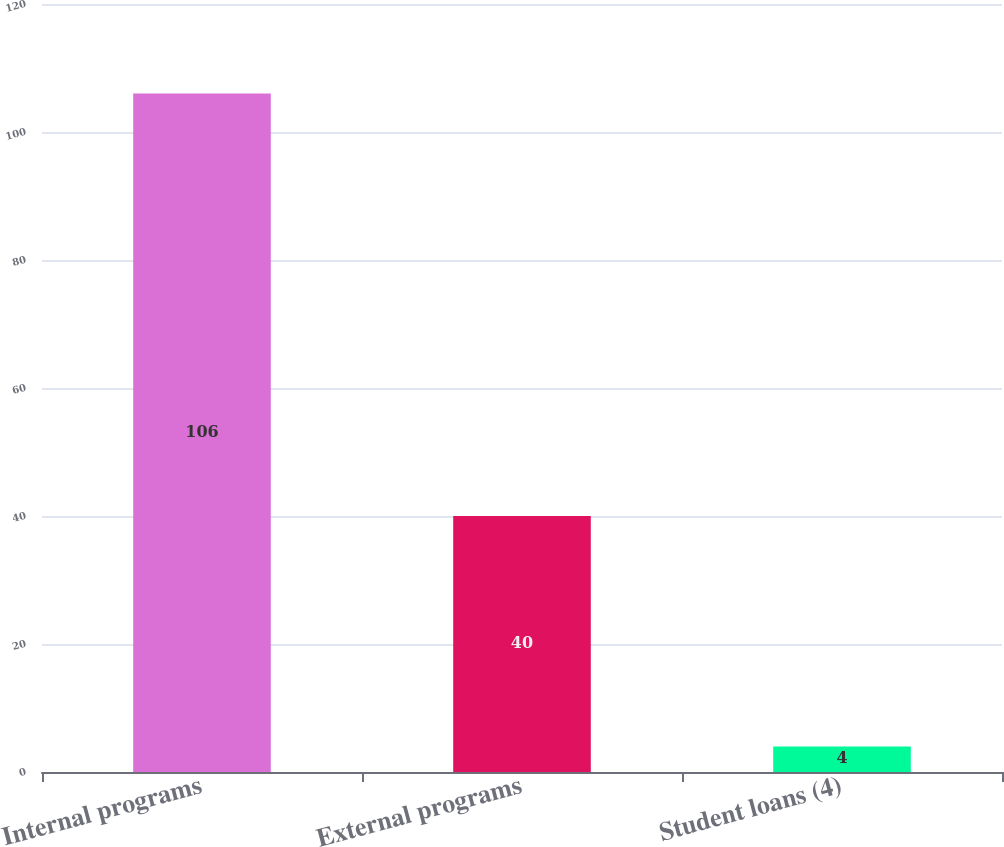<chart> <loc_0><loc_0><loc_500><loc_500><bar_chart><fcel>Internal programs<fcel>External programs<fcel>Student loans (4)<nl><fcel>106<fcel>40<fcel>4<nl></chart> 